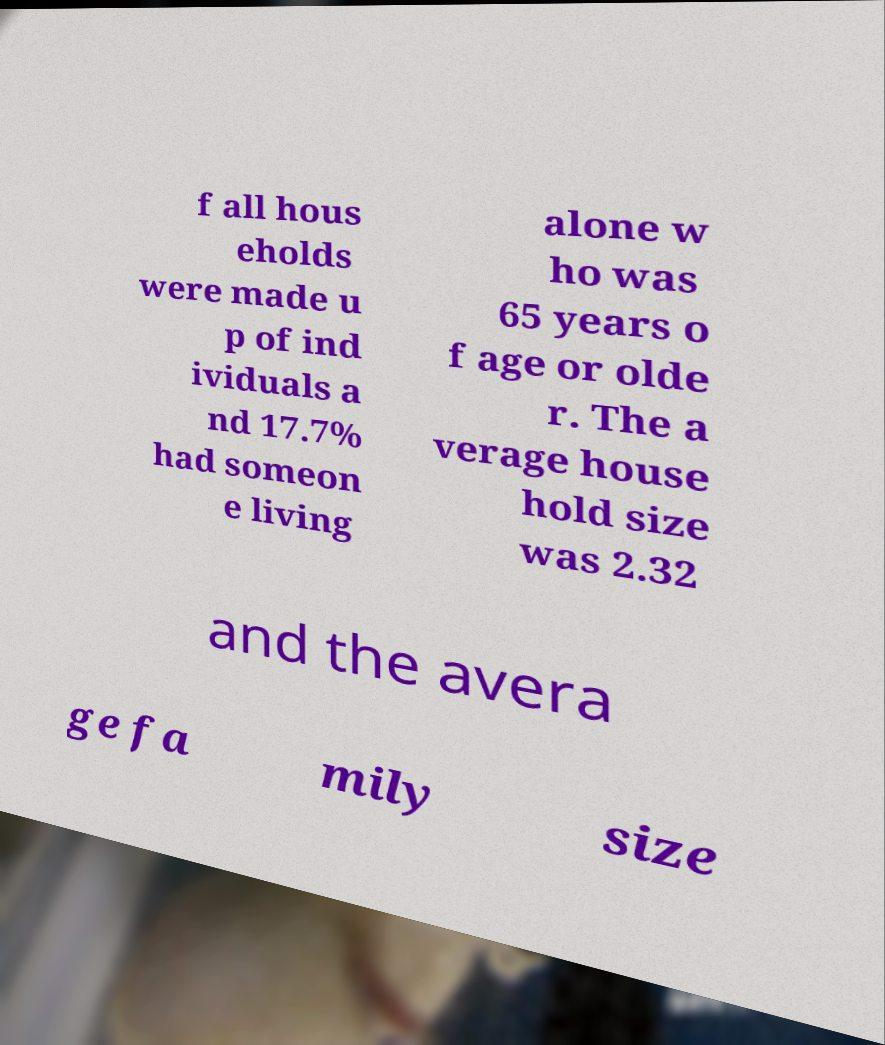Please identify and transcribe the text found in this image. f all hous eholds were made u p of ind ividuals a nd 17.7% had someon e living alone w ho was 65 years o f age or olde r. The a verage house hold size was 2.32 and the avera ge fa mily size 